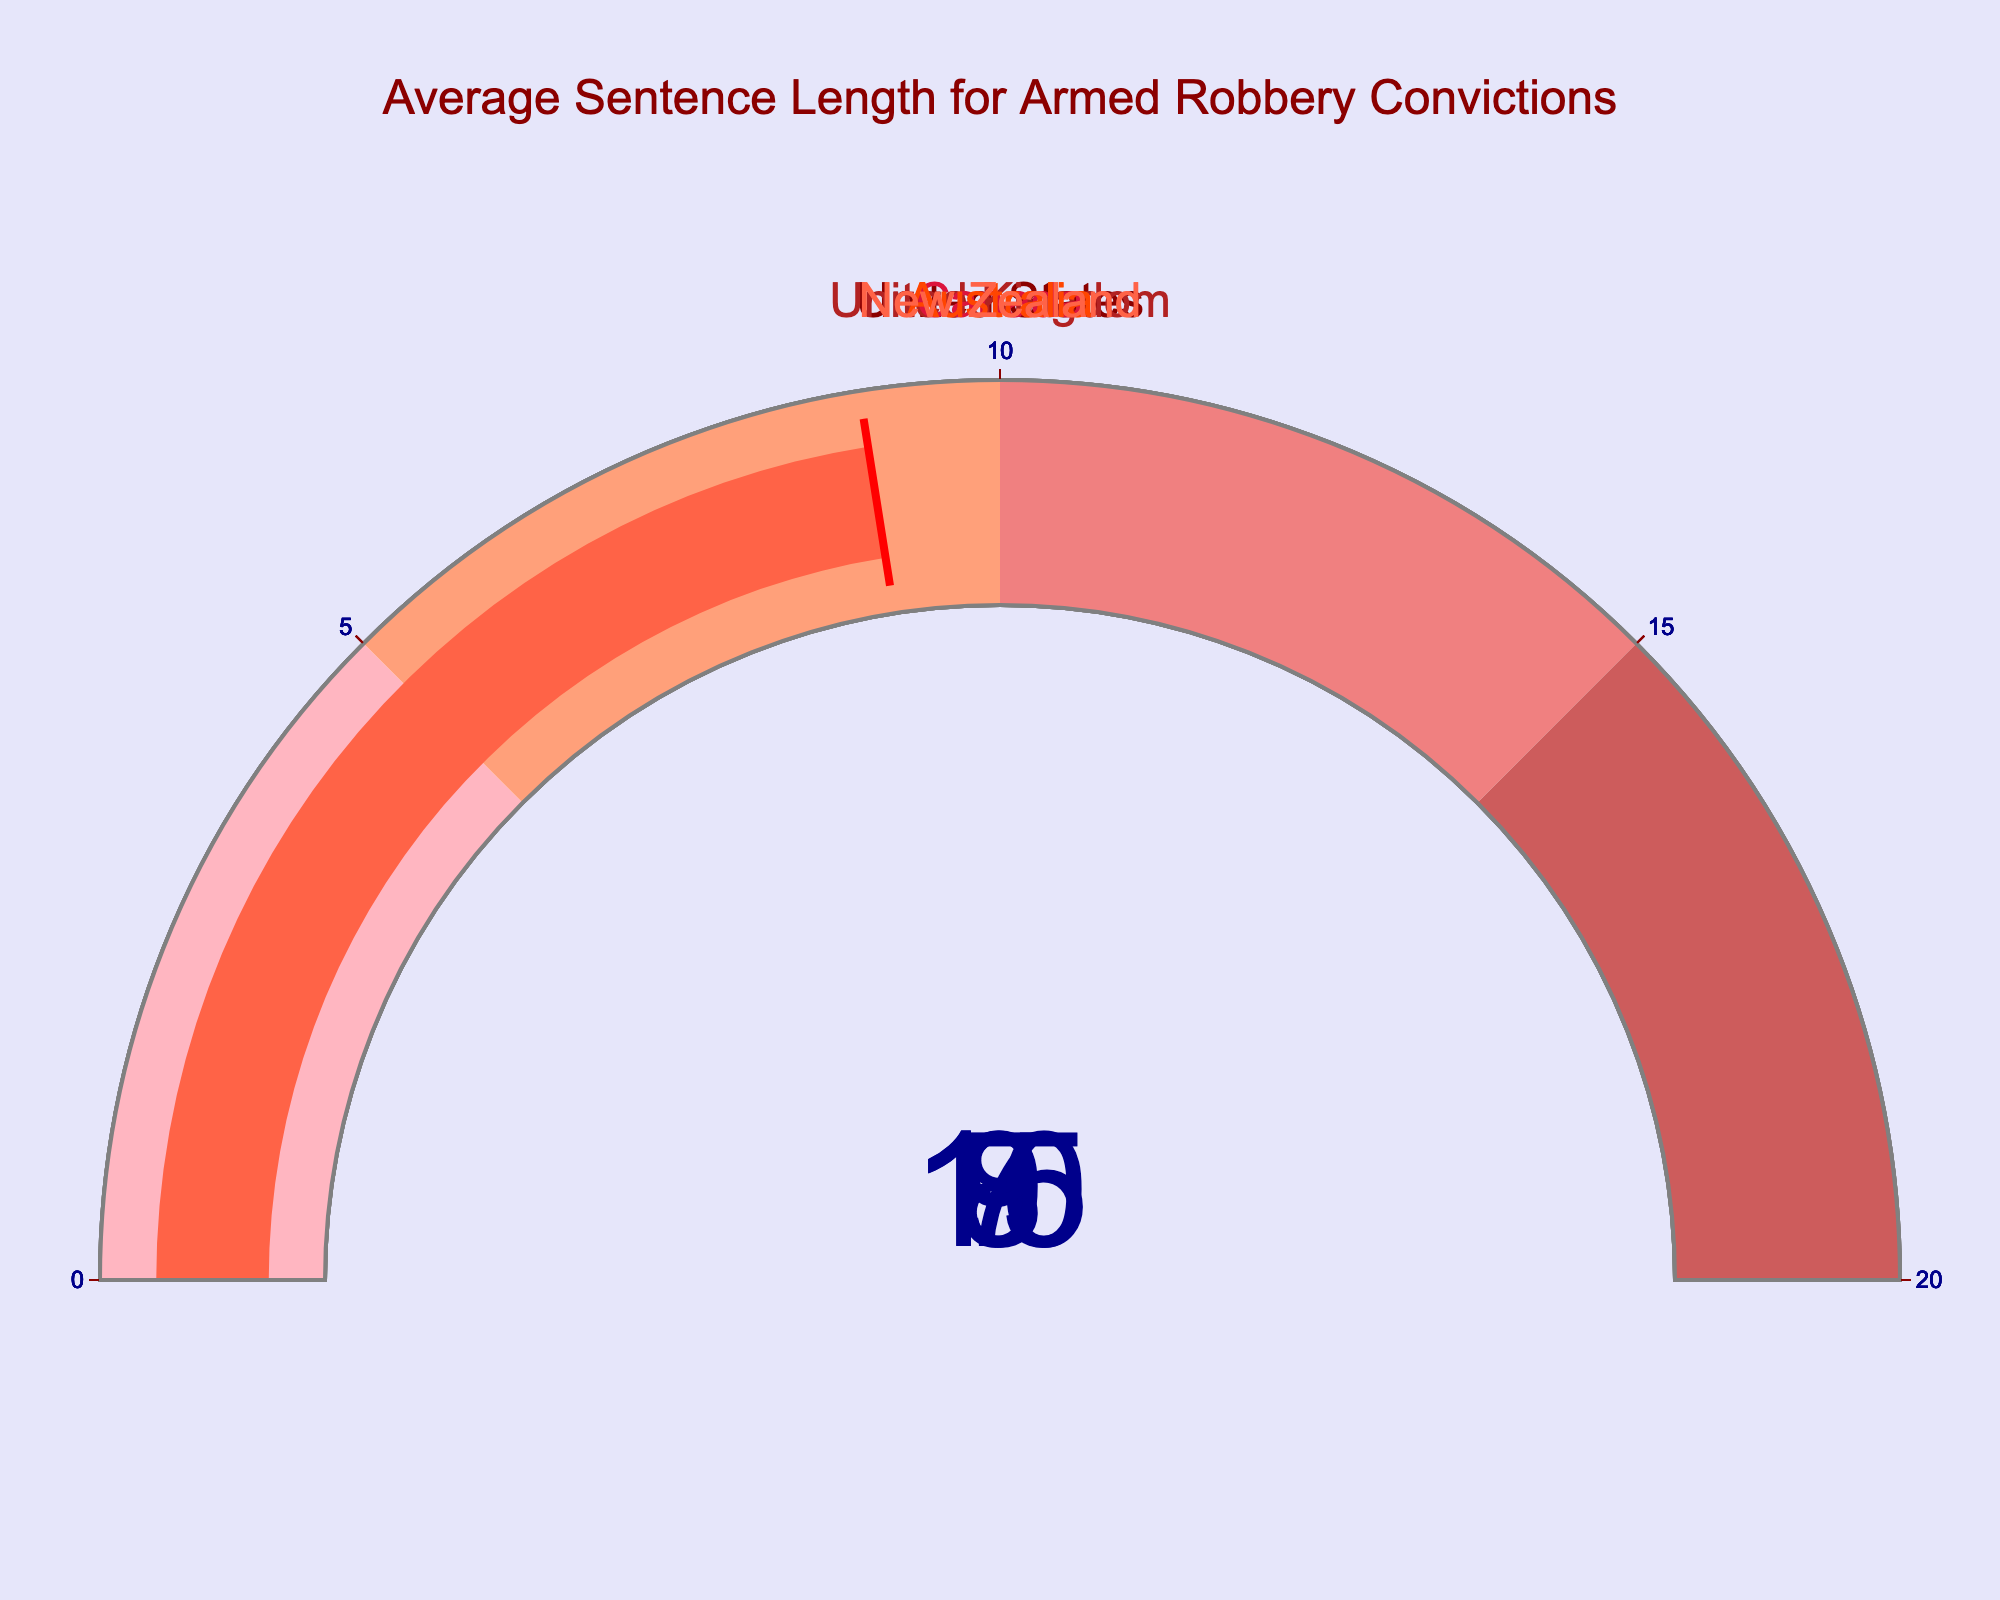What is the average sentence length for armed robbery convictions in the United States? The gauge chart for the United States shows a value of 15 years.
Answer: 15 years What is the shortest average sentence length for armed robbery convictions among the countries listed? Among the countries shown, Canada has the lowest value on its gauge, which is 7 years.
Answer: 7 years How many years longer is the average sentence length for armed robbery convictions in the United States compared to Canada? The U.S. has an average sentence of 15 years, and Canada has 7 years. The difference is 15 - 7 = 8 years.
Answer: 8 years Which country has the second highest average sentence length for armed robbery convictions? When comparing all the gauge values, the United States has the highest at 15 years, and Australia has the second highest at 10 years.
Answer: Australia What is the range of average sentence lengths for armed robbery convictions in the countries shown? The range is found by subtracting the smallest value from the largest. The United States has the largest value at 15 years, and Canada has the smallest at 7 years. So, the range is 15 - 7 = 8 years.
Answer: 8 years Are there any countries with an average sentence length for armed robbery convictions between 8 and 10 years? The countries with values in this range on their gauges are New Zealand with 9 years and Australia with 10 years.
Answer: New Zealand, Australia Which country has an average sentence length for armed robbery convictions that is closest to 9 years? New Zealand's gauge shows a value of 9 years, which is exactly 9 years and hence the closest.
Answer: New Zealand What is the mean average sentence length for armed robbery convictions across all listed countries? Adding all the average sentence lengths: 15 (U.S.) + 8 (U.K.) + 7 (Canada) + 10 (Australia) + 9 (New Zealand) = 49 years. Dividing by the number of countries (5) gives 49 / 5 = 9.8 years.
Answer: 9.8 years Which gauge color indicates the longest average sentence length for armed robbery convictions, and for which country? The United States has the longest average sentence length of 15 years, and its gauge color is a dark red.
Answer: Dark red, United States 